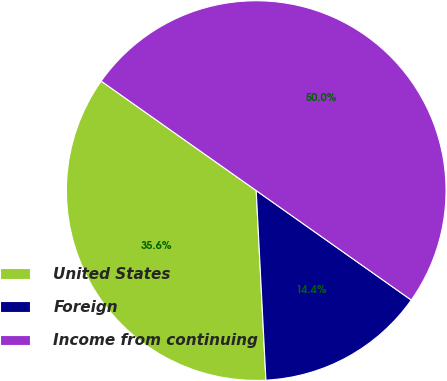<chart> <loc_0><loc_0><loc_500><loc_500><pie_chart><fcel>United States<fcel>Foreign<fcel>Income from continuing<nl><fcel>35.6%<fcel>14.4%<fcel>50.0%<nl></chart> 